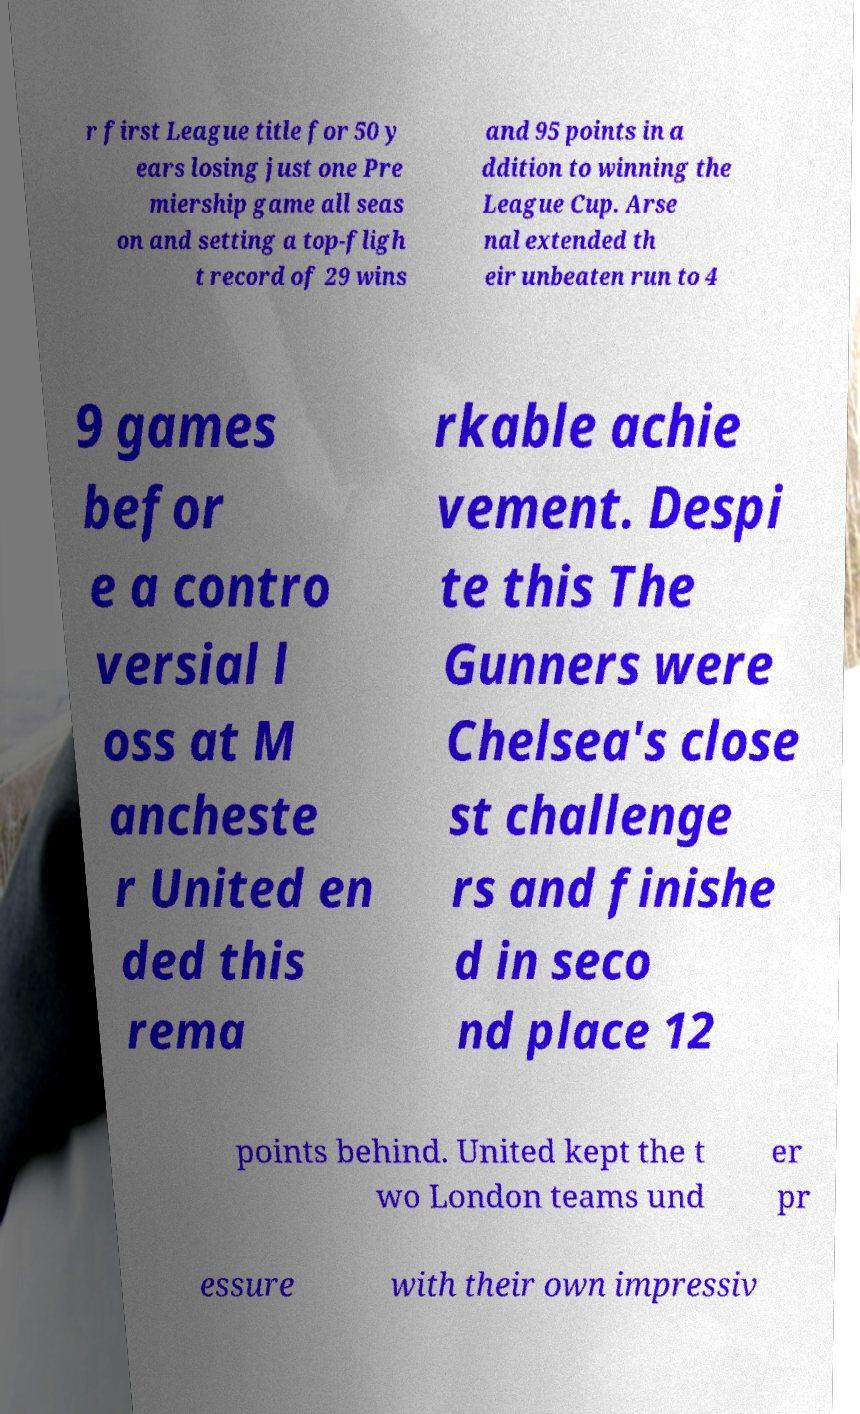Could you assist in decoding the text presented in this image and type it out clearly? r first League title for 50 y ears losing just one Pre miership game all seas on and setting a top-fligh t record of 29 wins and 95 points in a ddition to winning the League Cup. Arse nal extended th eir unbeaten run to 4 9 games befor e a contro versial l oss at M ancheste r United en ded this rema rkable achie vement. Despi te this The Gunners were Chelsea's close st challenge rs and finishe d in seco nd place 12 points behind. United kept the t wo London teams und er pr essure with their own impressiv 